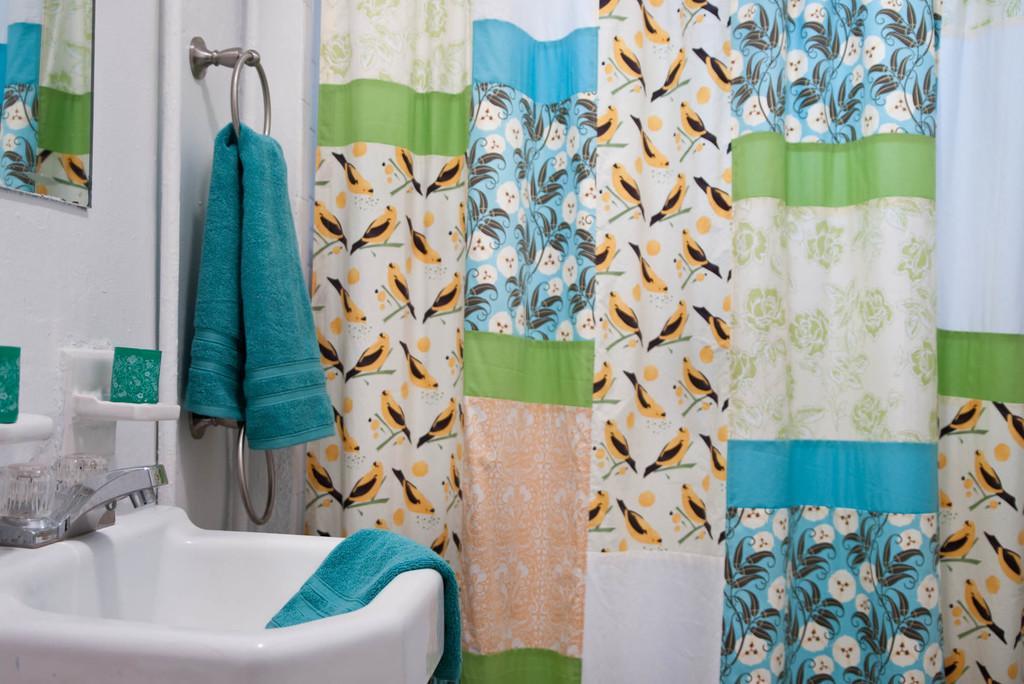How would you summarize this image in a sentence or two? In this image I can see a sink which is white in color, a tap and few towels which are blue in color. I can see the mirror and in the mirror I can see the reflection of the curtain which is cream, green, orange, blue and white in color. I can see the white colored wall and few objects which are green and white in color attached to the wall. 